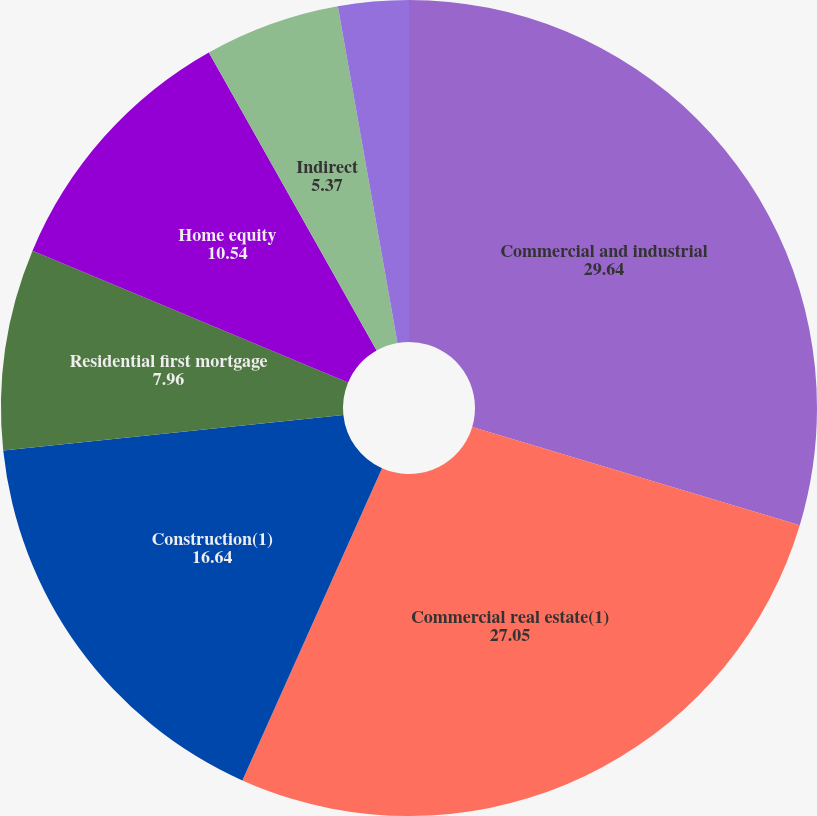Convert chart to OTSL. <chart><loc_0><loc_0><loc_500><loc_500><pie_chart><fcel>Commercial and industrial<fcel>Commercial real estate(1)<fcel>Construction(1)<fcel>Residential first mortgage<fcel>Home equity<fcel>Indirect<fcel>Other consumer<nl><fcel>29.64%<fcel>27.05%<fcel>16.64%<fcel>7.96%<fcel>10.54%<fcel>5.37%<fcel>2.79%<nl></chart> 